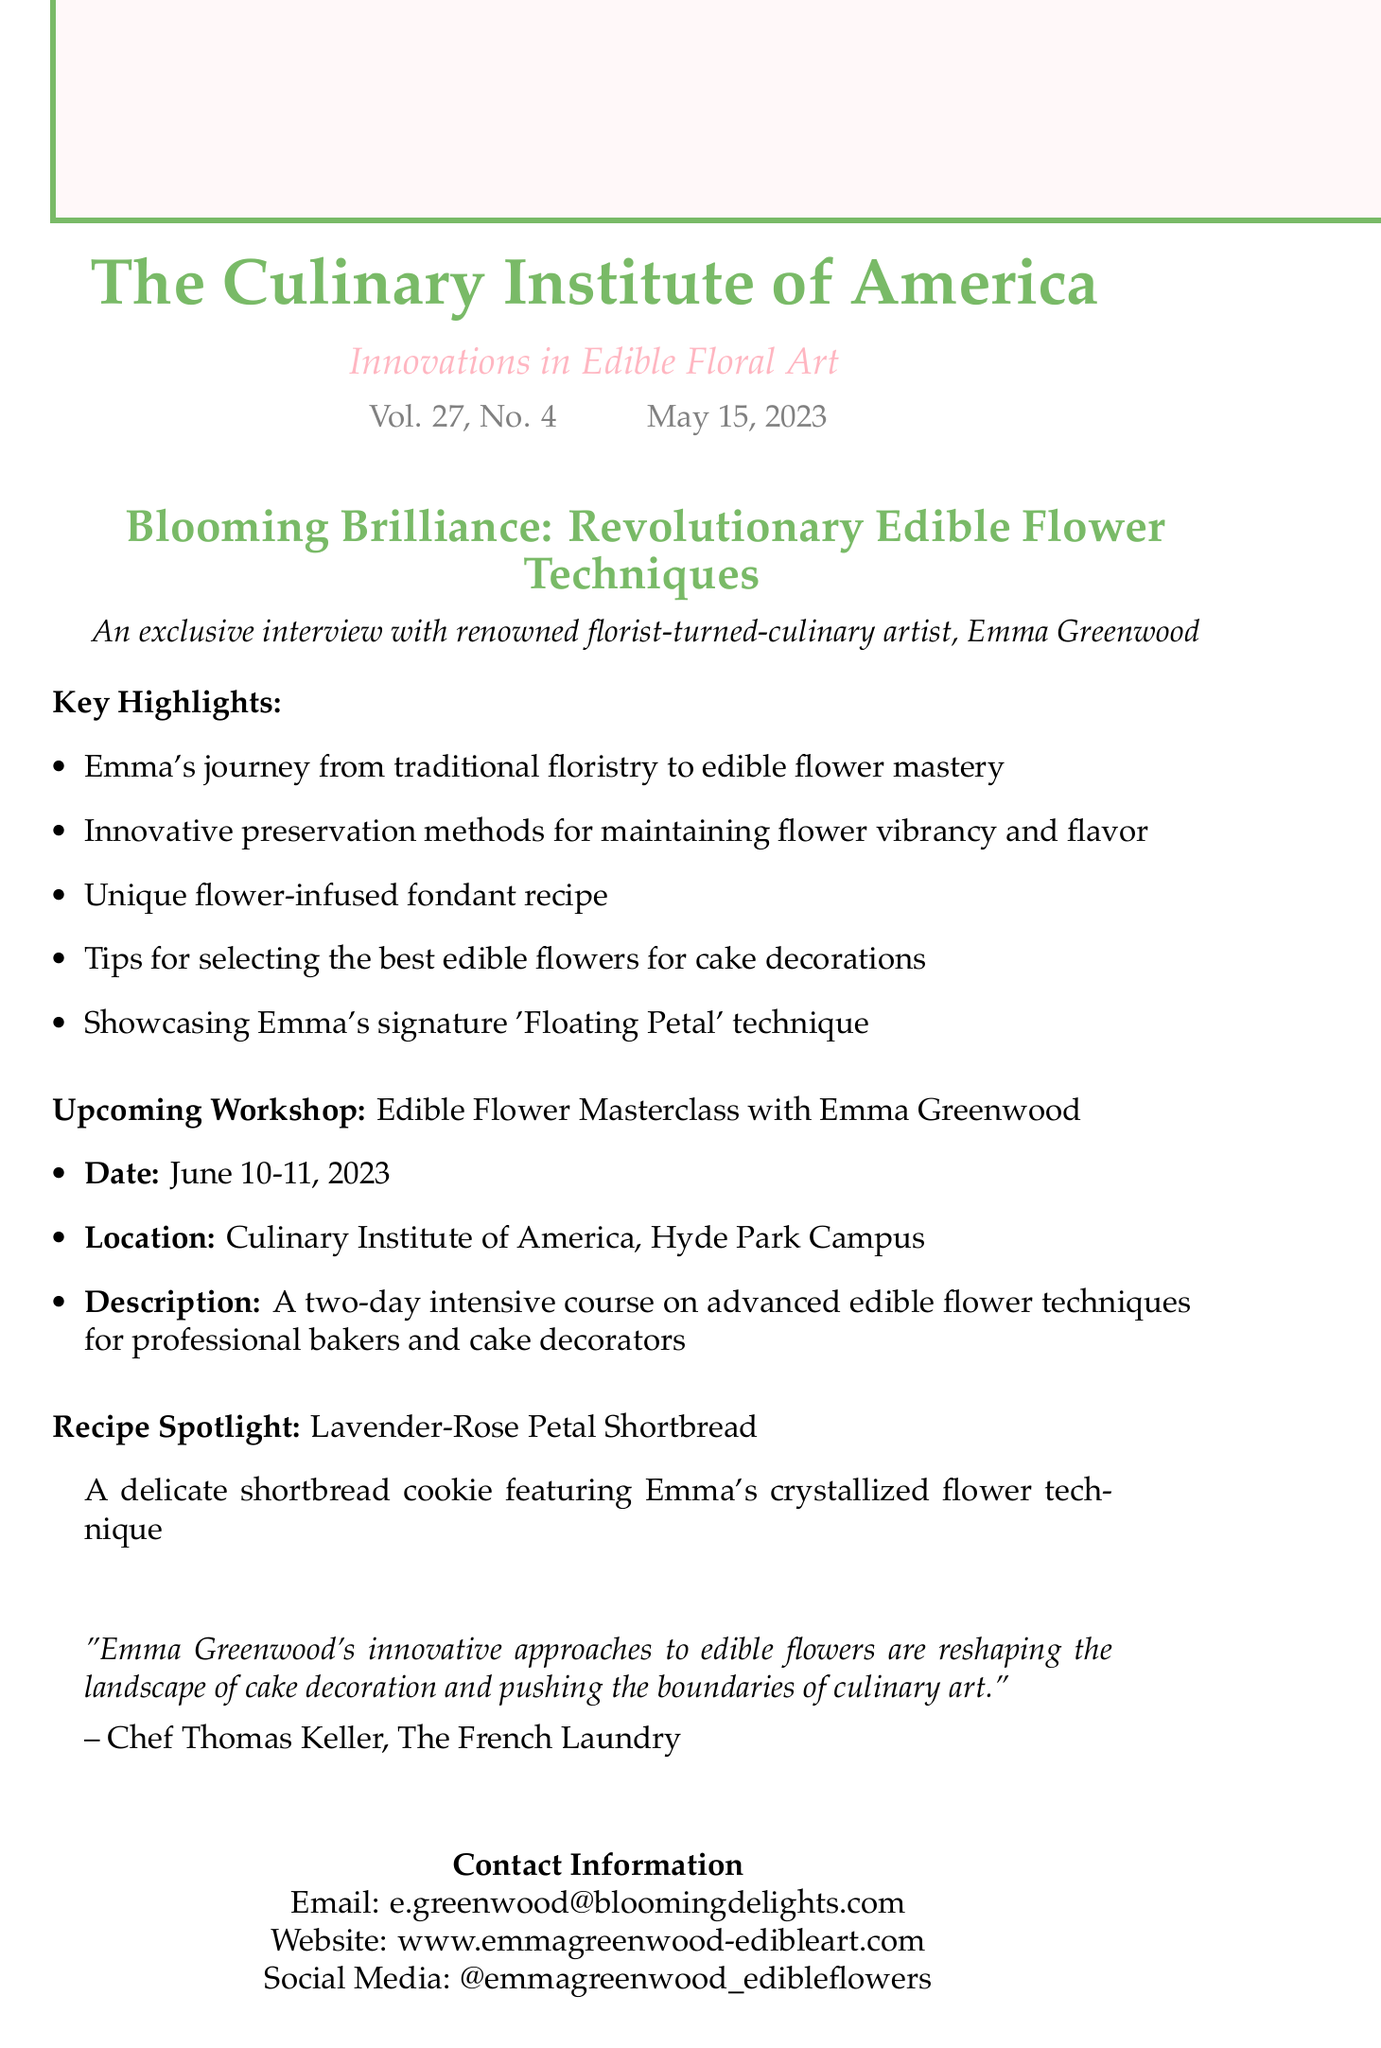What is the title of the featured article? The title of the featured article is "Blooming Brilliance: Revolutionary Edible Flower Techniques for Cake Decorations."
Answer: "Blooming Brilliance: Revolutionary Edible Flower Techniques for Cake Decorations" Who is the renowned florist featured in the interview? The renowned florist featured in the interview is Emma Greenwood.
Answer: Emma Greenwood What is the date of the upcoming workshop? The upcoming workshop is scheduled for June 10-11, 2023.
Answer: June 10-11, 2023 What unique recipe is spotlighted in the newsletter? The unique recipe spotlighted in the newsletter is Lavender-Rose Petal Shortbread.
Answer: Lavender-Rose Petal Shortbread Who quoted the impact of Emma Greenwood's work? The quote regarding the impact of Emma Greenwood's work was made by Chef Thomas Keller.
Answer: Chef Thomas Keller What technique is Emma's signature featured in the article? Emma's signature technique featured in the article is the "Floating Petal" technique.
Answer: Floating Petal What is the purpose of the newsletter? The purpose of the newsletter is to highlight innovations in edible floral art.
Answer: Innovations in edible floral art Where will the workshop take place? The workshop will take place at the Culinary Institute of America, Hyde Park Campus.
Answer: Culinary Institute of America, Hyde Park Campus 